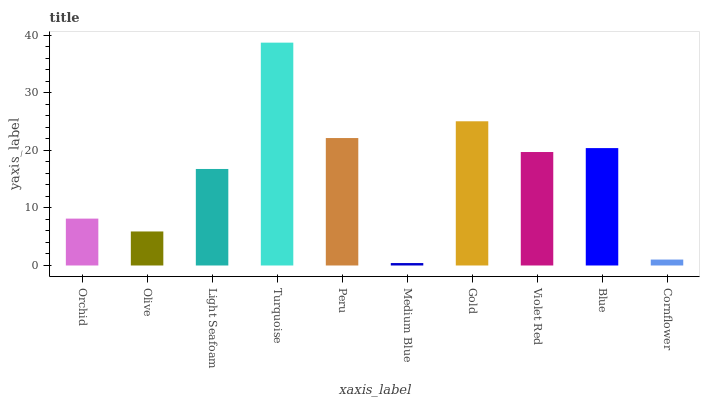Is Medium Blue the minimum?
Answer yes or no. Yes. Is Turquoise the maximum?
Answer yes or no. Yes. Is Olive the minimum?
Answer yes or no. No. Is Olive the maximum?
Answer yes or no. No. Is Orchid greater than Olive?
Answer yes or no. Yes. Is Olive less than Orchid?
Answer yes or no. Yes. Is Olive greater than Orchid?
Answer yes or no. No. Is Orchid less than Olive?
Answer yes or no. No. Is Violet Red the high median?
Answer yes or no. Yes. Is Light Seafoam the low median?
Answer yes or no. Yes. Is Turquoise the high median?
Answer yes or no. No. Is Blue the low median?
Answer yes or no. No. 